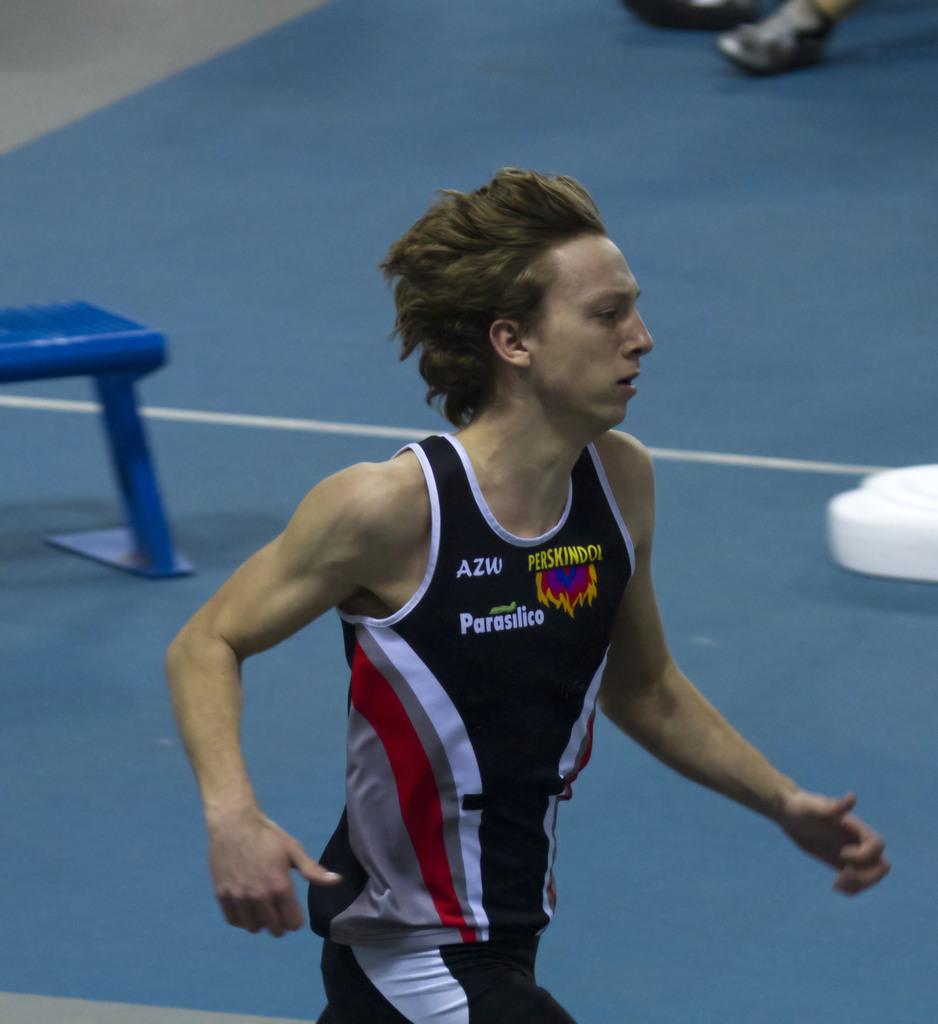What is written on the top left of his jersey?
Make the answer very short. Azw. 